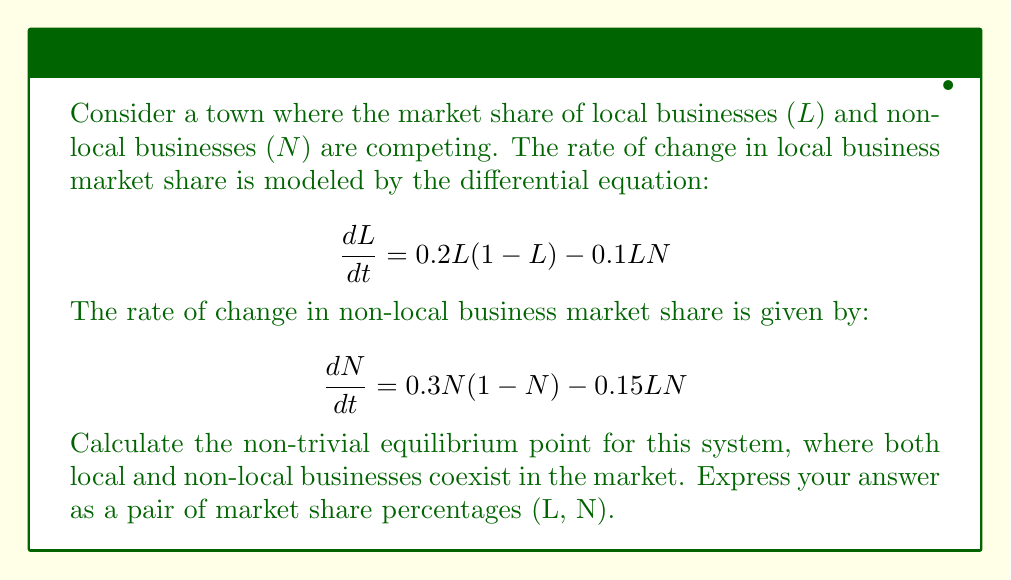Can you solve this math problem? To find the equilibrium point, we need to set both differential equations equal to zero and solve for L and N:

1) Set $\frac{dL}{dt} = 0$:
   $$0 = 0.2L(1-L) - 0.1LN$$

2) Set $\frac{dN}{dt} = 0$:
   $$0 = 0.3N(1-N) - 0.15LN$$

3) From equation 1:
   $$0.2L(1-L) = 0.1LN$$
   $$0.2(1-L) = 0.1N$$
   $$2(1-L) = N$$ ... (Equation A)

4) From equation 2:
   $$0.3N(1-N) = 0.15LN$$
   $$0.3(1-N) = 0.15L$$
   $$2(1-N) = L$$ ... (Equation B)

5) Substitute Equation A into Equation B:
   $$2(1-N) = L = 1 - \frac{N}{2}$$

6) Solve for N:
   $$2-2N = 1 - \frac{N}{2}$$
   $$2-1 = 2N - \frac{N}{2}$$
   $$1 = \frac{4N-N}{2} = \frac{3N}{2}$$
   $$N = \frac{2}{3}$$

7) Substitute N back into Equation A to find L:
   $$L = 1 - \frac{N}{2} = 1 - \frac{1}{3} = \frac{2}{3}$$

8) Convert to percentages:
   L = 66.67%, N = 66.67%
Answer: The non-trivial equilibrium point is (66.67%, 66.67%). 